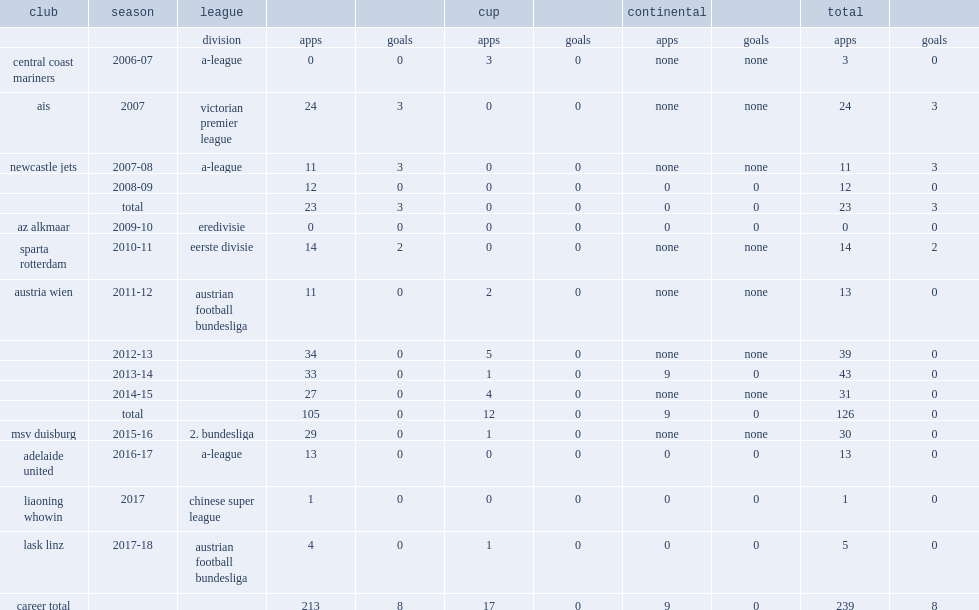In 2017, which club did holland join in chinese super league club? Liaoning whowin. 